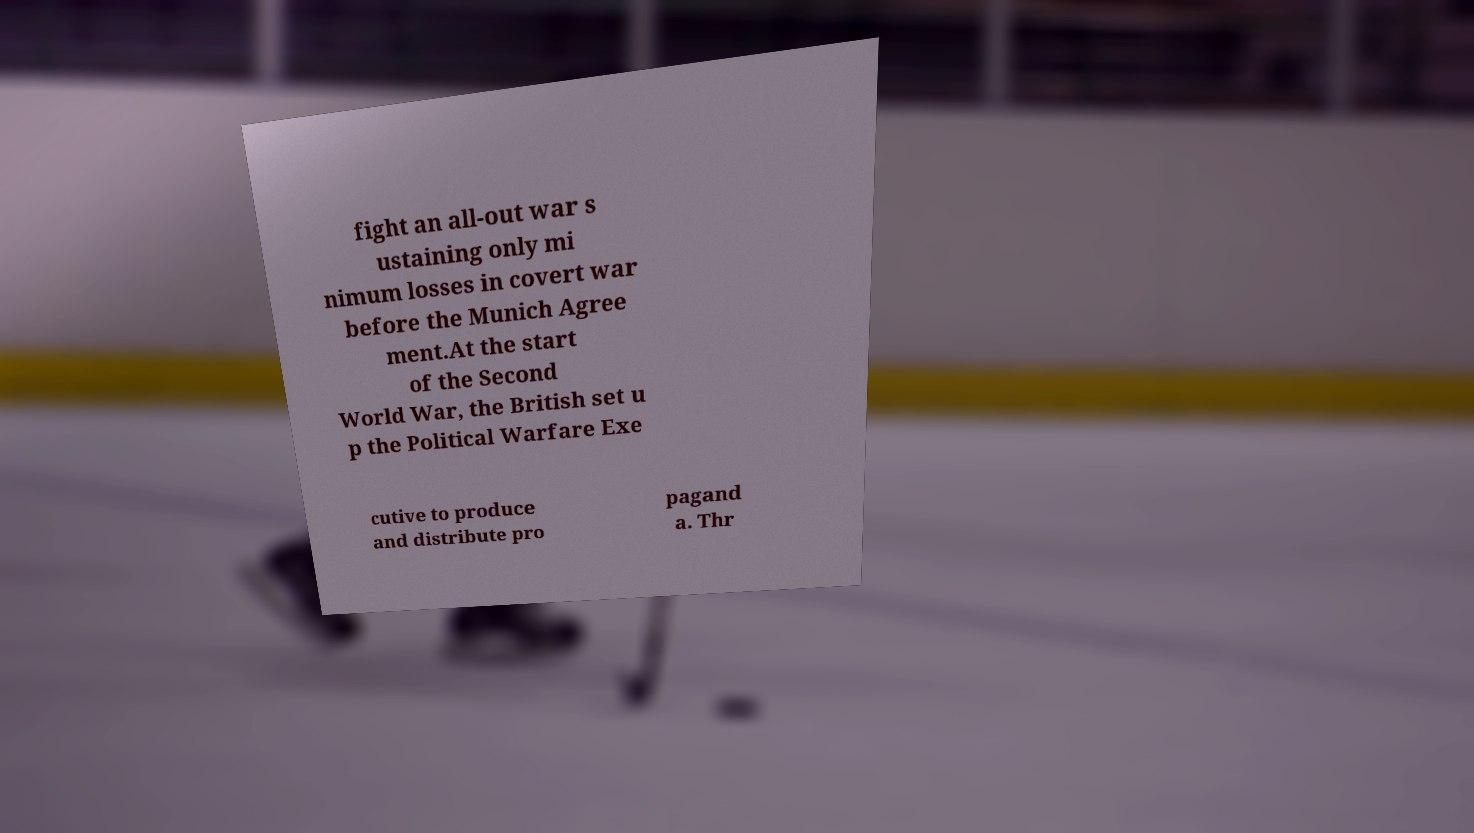What messages or text are displayed in this image? I need them in a readable, typed format. fight an all-out war s ustaining only mi nimum losses in covert war before the Munich Agree ment.At the start of the Second World War, the British set u p the Political Warfare Exe cutive to produce and distribute pro pagand a. Thr 